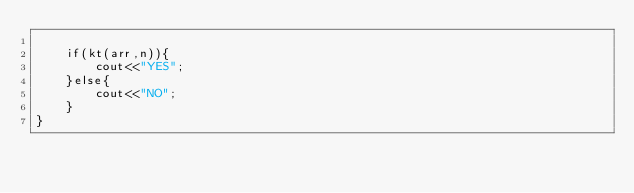Convert code to text. <code><loc_0><loc_0><loc_500><loc_500><_C++_>    
    if(kt(arr,n)){
        cout<<"YES";
    }else{
        cout<<"NO";
    }
}</code> 